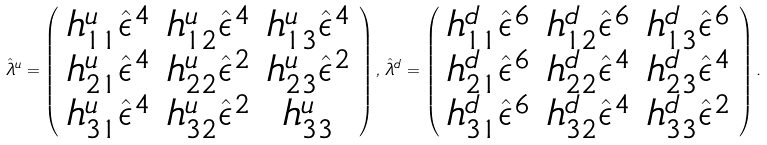Convert formula to latex. <formula><loc_0><loc_0><loc_500><loc_500>\hat { \lambda } ^ { u } = \left ( \begin{array} { c c c } h ^ { u } _ { 1 1 } \hat { \epsilon } ^ { 4 } & h ^ { u } _ { 1 2 } \hat { \epsilon } ^ { 4 } & h ^ { u } _ { 1 3 } \hat { \epsilon } ^ { 4 } \\ h ^ { u } _ { 2 1 } \hat { \epsilon } ^ { 4 } & h ^ { u } _ { 2 2 } \hat { \epsilon } ^ { 2 } & h ^ { u } _ { 2 3 } \hat { \epsilon } ^ { 2 } \\ h ^ { u } _ { 3 1 } \hat { \epsilon } ^ { 4 } & h ^ { u } _ { 3 2 } \hat { \epsilon } ^ { 2 } & h ^ { u } _ { 3 3 } \end{array} \right ) , \, \hat { \lambda } ^ { d } = \left ( \begin{array} { c c c } h ^ { d } _ { 1 1 } \hat { \epsilon } ^ { 6 } & h ^ { d } _ { 1 2 } \hat { \epsilon } ^ { 6 } & h ^ { d } _ { 1 3 } \hat { \epsilon } ^ { 6 } \\ h ^ { d } _ { 2 1 } \hat { \epsilon } ^ { 6 } & h ^ { d } _ { 2 2 } \hat { \epsilon } ^ { 4 } & h ^ { d } _ { 2 3 } \hat { \epsilon } ^ { 4 } \\ h ^ { d } _ { 3 1 } \hat { \epsilon } ^ { 6 } & h ^ { d } _ { 3 2 } \hat { \epsilon } ^ { 4 } & h ^ { d } _ { 3 3 } \hat { \epsilon } ^ { 2 } \end{array} \right ) .</formula> 